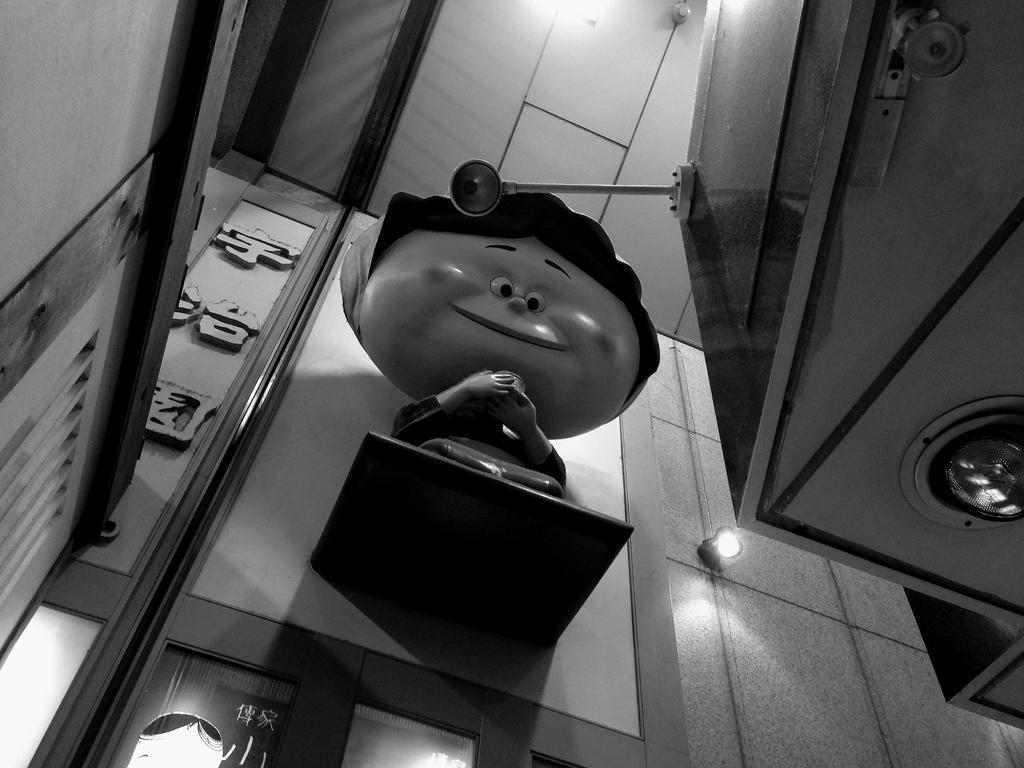In one or two sentences, can you explain what this image depicts? In this picture, we can see the wall with some objects attached to it like a toy on a holder, light, we can see some text on the wall, door, and we can see the roof with lights and with some objects, we can see some object in the top right corner of the picture. 